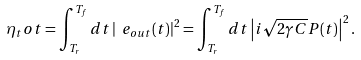Convert formula to latex. <formula><loc_0><loc_0><loc_500><loc_500>\eta _ { t } o t = \int _ { T _ { r } } ^ { T _ { f } } d t \left | \ e _ { o u t } ( t ) \right | ^ { 2 } = \int _ { T _ { r } } ^ { T _ { f } } d t \left | i \sqrt { 2 \gamma C } P ( t ) \right | ^ { 2 } .</formula> 